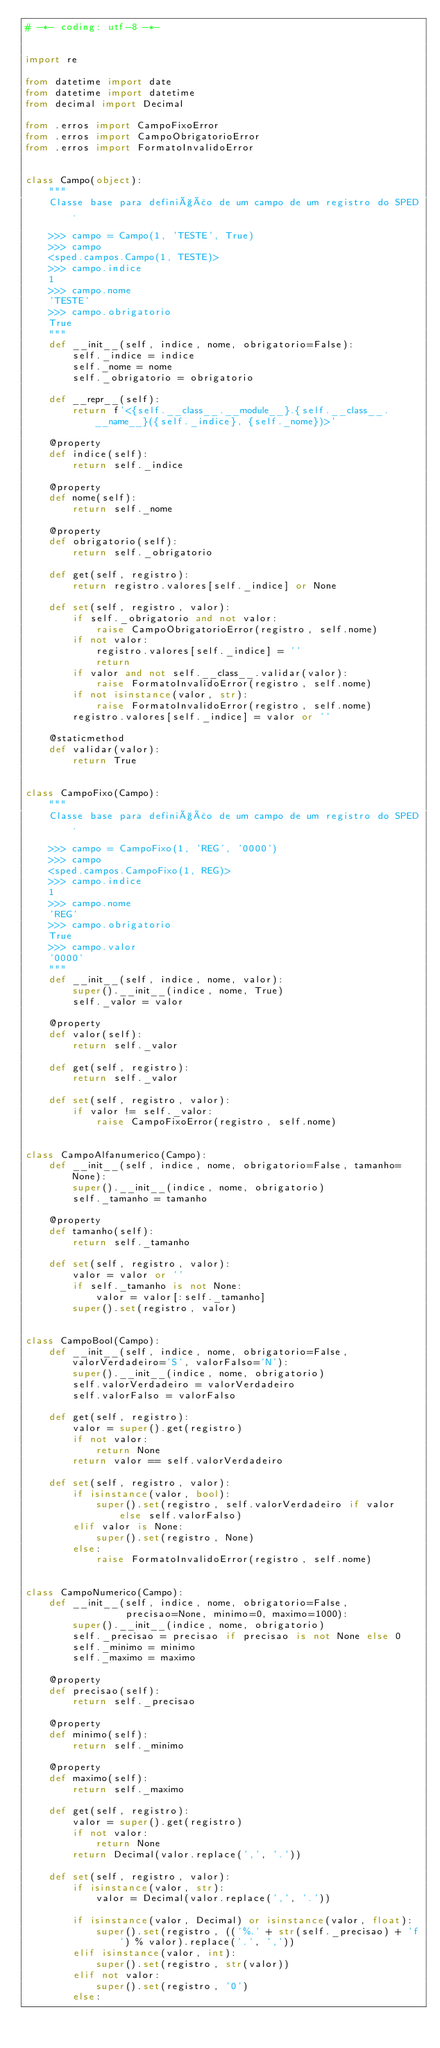<code> <loc_0><loc_0><loc_500><loc_500><_Python_># -*- coding: utf-8 -*-


import re

from datetime import date
from datetime import datetime
from decimal import Decimal

from .erros import CampoFixoError
from .erros import CampoObrigatorioError
from .erros import FormatoInvalidoError


class Campo(object):
    """
    Classe base para definição de um campo de um registro do SPED.

    >>> campo = Campo(1, 'TESTE', True)
    >>> campo
    <sped.campos.Campo(1, TESTE)>
    >>> campo.indice
    1
    >>> campo.nome
    'TESTE'
    >>> campo.obrigatorio
    True
    """
    def __init__(self, indice, nome, obrigatorio=False):
        self._indice = indice
        self._nome = nome
        self._obrigatorio = obrigatorio

    def __repr__(self):
        return f'<{self.__class__.__module__}.{self.__class__.__name__}({self._indice}, {self._nome})>'

    @property
    def indice(self):
        return self._indice

    @property
    def nome(self):
        return self._nome

    @property
    def obrigatorio(self):
        return self._obrigatorio

    def get(self, registro):
        return registro.valores[self._indice] or None

    def set(self, registro, valor):
        if self._obrigatorio and not valor:
            raise CampoObrigatorioError(registro, self.nome)
        if not valor:
            registro.valores[self._indice] = ''
            return
        if valor and not self.__class__.validar(valor):
            raise FormatoInvalidoError(registro, self.nome)
        if not isinstance(valor, str):
            raise FormatoInvalidoError(registro, self.nome)
        registro.valores[self._indice] = valor or ''

    @staticmethod
    def validar(valor):
        return True


class CampoFixo(Campo):
    """
    Classe base para definição de um campo de um registro do SPED.

    >>> campo = CampoFixo(1, 'REG', '0000')
    >>> campo
    <sped.campos.CampoFixo(1, REG)>
    >>> campo.indice
    1
    >>> campo.nome
    'REG'
    >>> campo.obrigatorio
    True
    >>> campo.valor
    '0000'
    """
    def __init__(self, indice, nome, valor):
        super().__init__(indice, nome, True)
        self._valor = valor

    @property
    def valor(self):
        return self._valor

    def get(self, registro):
        return self._valor

    def set(self, registro, valor):
        if valor != self._valor:
            raise CampoFixoError(registro, self.nome)


class CampoAlfanumerico(Campo):
    def __init__(self, indice, nome, obrigatorio=False, tamanho=None):
        super().__init__(indice, nome, obrigatorio)
        self._tamanho = tamanho

    @property
    def tamanho(self):
        return self._tamanho

    def set(self, registro, valor):
        valor = valor or ''
        if self._tamanho is not None:
            valor = valor[:self._tamanho]
        super().set(registro, valor)


class CampoBool(Campo):
    def __init__(self, indice, nome, obrigatorio=False, valorVerdadeiro='S', valorFalso='N'):
        super().__init__(indice, nome, obrigatorio)
        self.valorVerdadeiro = valorVerdadeiro
        self.valorFalso = valorFalso

    def get(self, registro):
        valor = super().get(registro)
        if not valor:
            return None
        return valor == self.valorVerdadeiro

    def set(self, registro, valor):
        if isinstance(valor, bool):
            super().set(registro, self.valorVerdadeiro if valor else self.valorFalso)
        elif valor is None:
            super().set(registro, None)
        else:
            raise FormatoInvalidoError(registro, self.nome)


class CampoNumerico(Campo):
    def __init__(self, indice, nome, obrigatorio=False,
                 precisao=None, minimo=0, maximo=1000):
        super().__init__(indice, nome, obrigatorio)
        self._precisao = precisao if precisao is not None else 0
        self._minimo = minimo
        self._maximo = maximo

    @property
    def precisao(self):
        return self._precisao

    @property
    def minimo(self):
        return self._minimo

    @property
    def maximo(self):
        return self._maximo

    def get(self, registro):
        valor = super().get(registro)
        if not valor:
            return None
        return Decimal(valor.replace(',', '.'))

    def set(self, registro, valor):
        if isinstance(valor, str):
            valor = Decimal(valor.replace(',', '.'))

        if isinstance(valor, Decimal) or isinstance(valor, float):
            super().set(registro, (('%.' + str(self._precisao) + 'f') % valor).replace('.', ','))
        elif isinstance(valor, int):
            super().set(registro, str(valor))
        elif not valor:
            super().set(registro, '0')
        else:</code> 